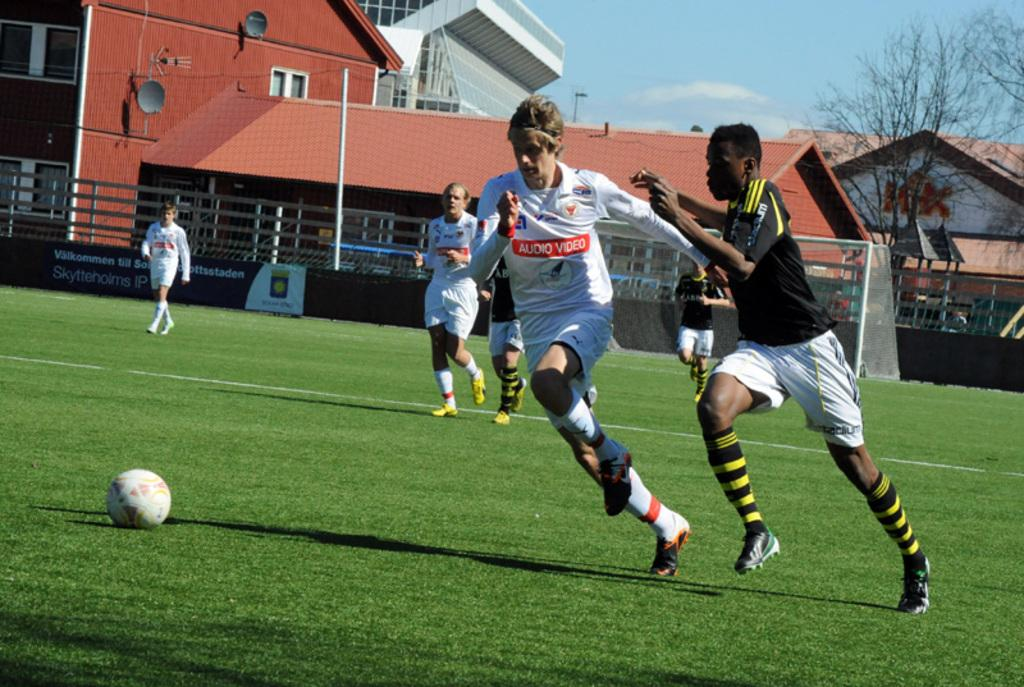Provide a one-sentence caption for the provided image. Two soccer players, one wearing an "Audio Video" jersey chase the ball. 